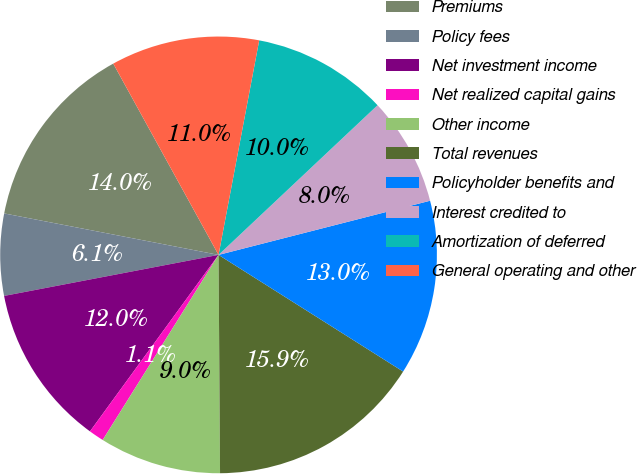Convert chart. <chart><loc_0><loc_0><loc_500><loc_500><pie_chart><fcel>Premiums<fcel>Policy fees<fcel>Net investment income<fcel>Net realized capital gains<fcel>Other income<fcel>Total revenues<fcel>Policyholder benefits and<fcel>Interest credited to<fcel>Amortization of deferred<fcel>General operating and other<nl><fcel>13.95%<fcel>6.05%<fcel>11.97%<fcel>1.12%<fcel>9.01%<fcel>15.92%<fcel>12.96%<fcel>8.03%<fcel>10.0%<fcel>10.99%<nl></chart> 